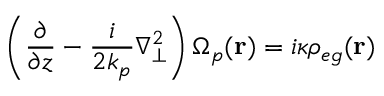<formula> <loc_0><loc_0><loc_500><loc_500>\left ( \frac { \partial } { \partial z } - \frac { i } { 2 k _ { p } } \nabla _ { \bot } ^ { 2 } \right ) \Omega _ { p } ( r ) = i \kappa \rho _ { e g } ( r )</formula> 